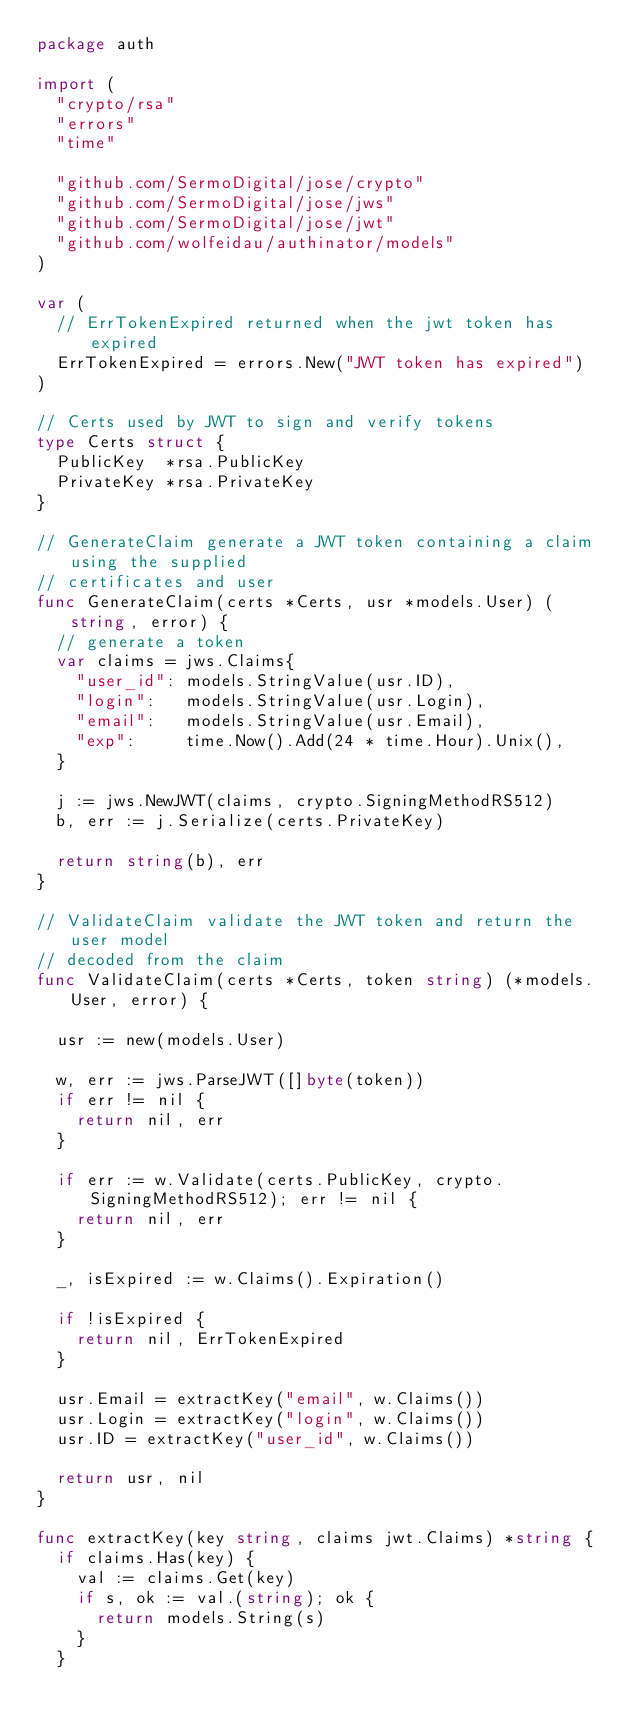Convert code to text. <code><loc_0><loc_0><loc_500><loc_500><_Go_>package auth

import (
	"crypto/rsa"
	"errors"
	"time"

	"github.com/SermoDigital/jose/crypto"
	"github.com/SermoDigital/jose/jws"
	"github.com/SermoDigital/jose/jwt"
	"github.com/wolfeidau/authinator/models"
)

var (
	// ErrTokenExpired returned when the jwt token has expired
	ErrTokenExpired = errors.New("JWT token has expired")
)

// Certs used by JWT to sign and verify tokens
type Certs struct {
	PublicKey  *rsa.PublicKey
	PrivateKey *rsa.PrivateKey
}

// GenerateClaim generate a JWT token containing a claim using the supplied
// certificates and user
func GenerateClaim(certs *Certs, usr *models.User) (string, error) {
	// generate a token
	var claims = jws.Claims{
		"user_id": models.StringValue(usr.ID),
		"login":   models.StringValue(usr.Login),
		"email":   models.StringValue(usr.Email),
		"exp":     time.Now().Add(24 * time.Hour).Unix(),
	}

	j := jws.NewJWT(claims, crypto.SigningMethodRS512)
	b, err := j.Serialize(certs.PrivateKey)

	return string(b), err
}

// ValidateClaim validate the JWT token and return the user model
// decoded from the claim
func ValidateClaim(certs *Certs, token string) (*models.User, error) {

	usr := new(models.User)

	w, err := jws.ParseJWT([]byte(token))
	if err != nil {
		return nil, err
	}

	if err := w.Validate(certs.PublicKey, crypto.SigningMethodRS512); err != nil {
		return nil, err
	}

	_, isExpired := w.Claims().Expiration()

	if !isExpired {
		return nil, ErrTokenExpired
	}

	usr.Email = extractKey("email", w.Claims())
	usr.Login = extractKey("login", w.Claims())
	usr.ID = extractKey("user_id", w.Claims())

	return usr, nil
}

func extractKey(key string, claims jwt.Claims) *string {
	if claims.Has(key) {
		val := claims.Get(key)
		if s, ok := val.(string); ok {
			return models.String(s)
		}
	}</code> 